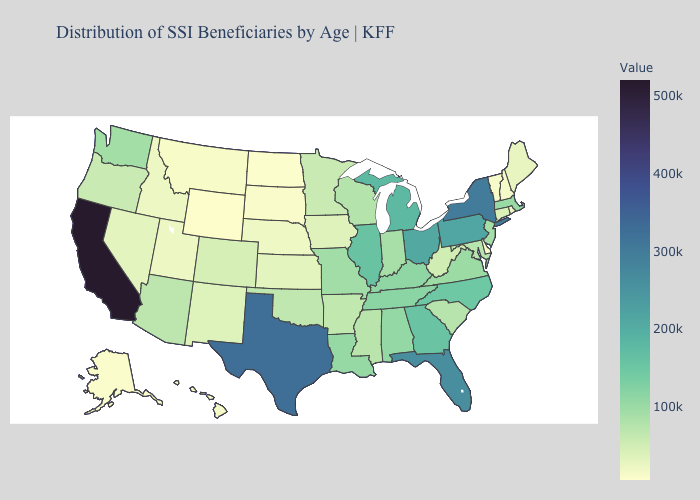Does Florida have the highest value in the South?
Write a very short answer. No. Which states have the highest value in the USA?
Quick response, please. California. Which states have the highest value in the USA?
Keep it brief. California. Among the states that border Delaware , which have the lowest value?
Concise answer only. Maryland. Does Mississippi have the lowest value in the USA?
Write a very short answer. No. Does Iowa have the lowest value in the MidWest?
Write a very short answer. No. Which states have the lowest value in the West?
Be succinct. Wyoming. 